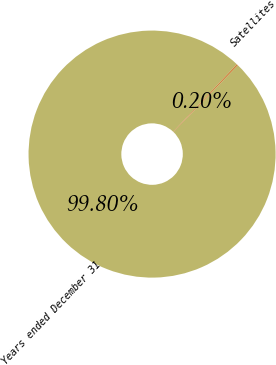Convert chart. <chart><loc_0><loc_0><loc_500><loc_500><pie_chart><fcel>Years ended December 31<fcel>Satellites<nl><fcel>99.8%<fcel>0.2%<nl></chart> 